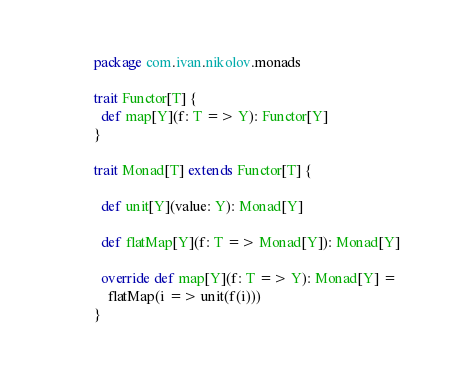<code> <loc_0><loc_0><loc_500><loc_500><_Scala_>package com.ivan.nikolov.monads

trait Functor[T] {
  def map[Y](f: T => Y): Functor[Y]
}

trait Monad[T] extends Functor[T] {

  def unit[Y](value: Y): Monad[Y]
  
  def flatMap[Y](f: T => Monad[Y]): Monad[Y]
  
  override def map[Y](f: T => Y): Monad[Y] =
    flatMap(i => unit(f(i)))
}</code> 